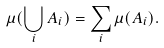Convert formula to latex. <formula><loc_0><loc_0><loc_500><loc_500>\mu ( \bigcup _ { i } A _ { i } ) = \sum _ { i } \mu ( A _ { i } ) .</formula> 